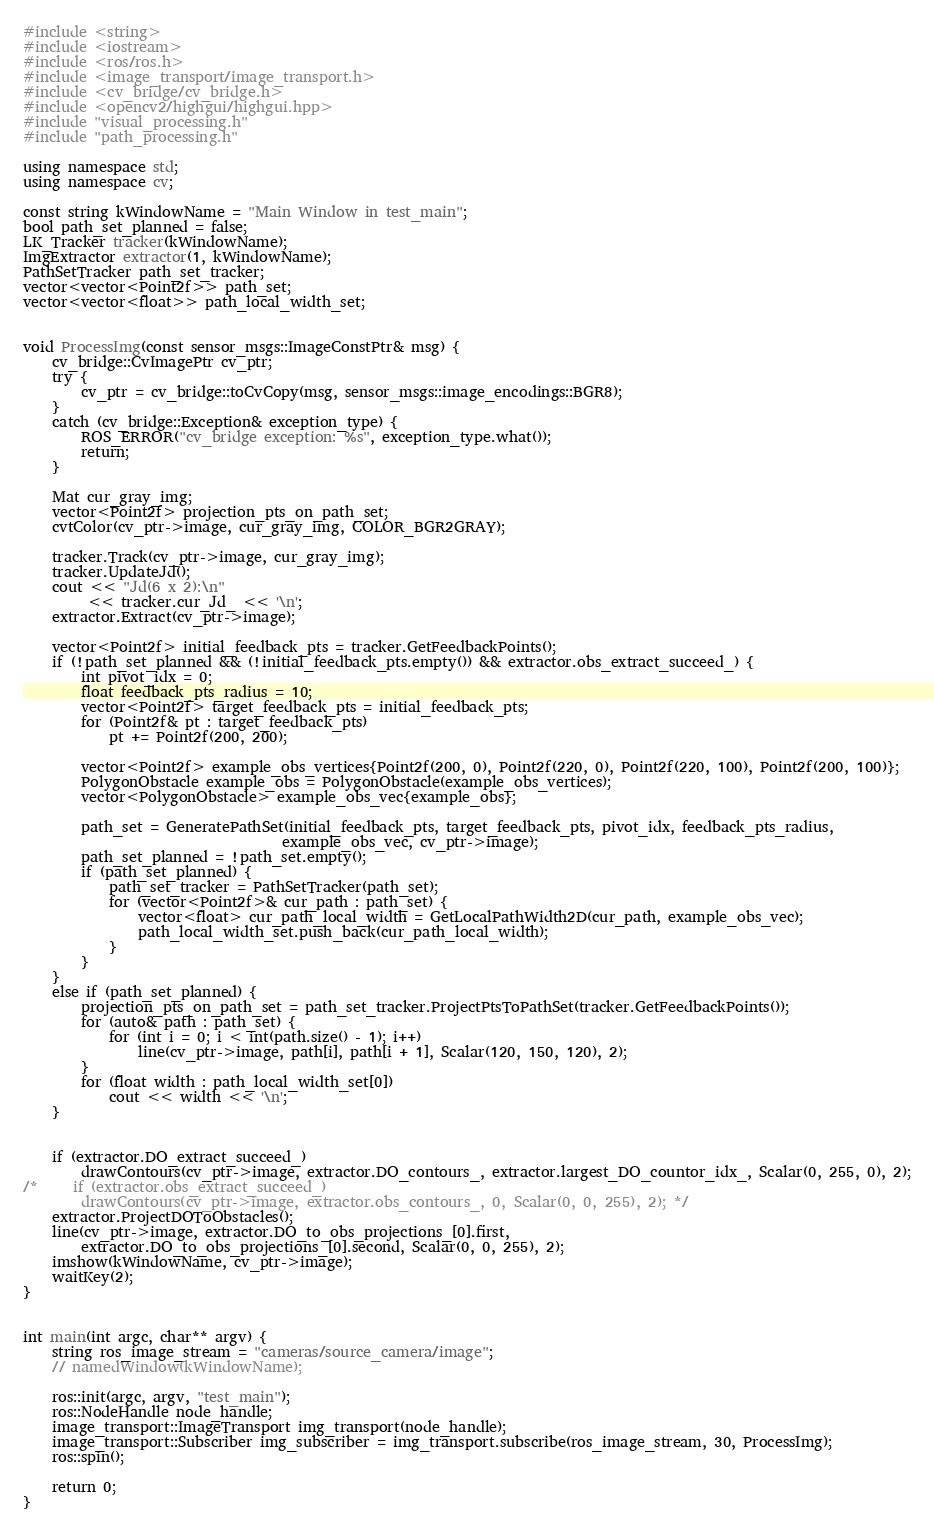Convert code to text. <code><loc_0><loc_0><loc_500><loc_500><_C++_>#include <string>
#include <iostream>
#include <ros/ros.h>
#include <image_transport/image_transport.h>
#include <cv_bridge/cv_bridge.h>
#include <opencv2/highgui/highgui.hpp>
#include "visual_processing.h"
#include "path_processing.h"

using namespace std;
using namespace cv;

const string kWindowName = "Main Window in test_main";
bool path_set_planned = false;
LK_Tracker tracker(kWindowName);
ImgExtractor extractor(1, kWindowName);
PathSetTracker path_set_tracker;
vector<vector<Point2f>> path_set;
vector<vector<float>> path_local_width_set;


void ProcessImg(const sensor_msgs::ImageConstPtr& msg) {
    cv_bridge::CvImagePtr cv_ptr;
    try {
        cv_ptr = cv_bridge::toCvCopy(msg, sensor_msgs::image_encodings::BGR8);
    }
    catch (cv_bridge::Exception& exception_type) {
        ROS_ERROR("cv_bridge exception: %s", exception_type.what());
        return;
    }

    Mat cur_gray_img;
    vector<Point2f> projection_pts_on_path_set;
    cvtColor(cv_ptr->image, cur_gray_img, COLOR_BGR2GRAY); 
    
    tracker.Track(cv_ptr->image, cur_gray_img);   
    tracker.UpdateJd();
    cout << "Jd(6 x 2):\n" 
         << tracker.cur_Jd_ << '\n';
    extractor.Extract(cv_ptr->image);
    
    vector<Point2f> initial_feedback_pts = tracker.GetFeedbackPoints();
    if (!path_set_planned && (!initial_feedback_pts.empty()) && extractor.obs_extract_succeed_) {
        int pivot_idx = 0;
        float feedback_pts_radius = 10;
        vector<Point2f> target_feedback_pts = initial_feedback_pts;
        for (Point2f& pt : target_feedback_pts)
            pt += Point2f(200, 200);

        vector<Point2f> example_obs_vertices{Point2f(200, 0), Point2f(220, 0), Point2f(220, 100), Point2f(200, 100)};
        PolygonObstacle example_obs = PolygonObstacle(example_obs_vertices);
        vector<PolygonObstacle> example_obs_vec{example_obs};
        
        path_set = GeneratePathSet(initial_feedback_pts, target_feedback_pts, pivot_idx, feedback_pts_radius,
                                    example_obs_vec, cv_ptr->image);
        path_set_planned = !path_set.empty();
        if (path_set_planned) {
            path_set_tracker = PathSetTracker(path_set);
            for (vector<Point2f>& cur_path : path_set) {
                vector<float> cur_path_local_width = GetLocalPathWidth2D(cur_path, example_obs_vec);
                path_local_width_set.push_back(cur_path_local_width);
            }
        }
    }
    else if (path_set_planned) {
        projection_pts_on_path_set = path_set_tracker.ProjectPtsToPathSet(tracker.GetFeedbackPoints());
        for (auto& path : path_set) {
            for (int i = 0; i < int(path.size() - 1); i++)
                line(cv_ptr->image, path[i], path[i + 1], Scalar(120, 150, 120), 2);
        }
        for (float width : path_local_width_set[0])
            cout << width << '\n';
    }


    if (extractor.DO_extract_succeed_)
        drawContours(cv_ptr->image, extractor.DO_contours_, extractor.largest_DO_countor_idx_, Scalar(0, 255, 0), 2);
/*     if (extractor.obs_extract_succeed_)
        drawContours(cv_ptr->image, extractor.obs_contours_, 0, Scalar(0, 0, 255), 2); */
    extractor.ProjectDOToObstacles();
    line(cv_ptr->image, extractor.DO_to_obs_projections_[0].first, 
        extractor.DO_to_obs_projections_[0].second, Scalar(0, 0, 255), 2);
    imshow(kWindowName, cv_ptr->image);
    waitKey(2);
}


int main(int argc, char** argv) {
    string ros_image_stream = "cameras/source_camera/image";
    // namedWindow(kWindowName);
    
    ros::init(argc, argv, "test_main");
    ros::NodeHandle node_handle;
    image_transport::ImageTransport img_transport(node_handle);
    image_transport::Subscriber img_subscriber = img_transport.subscribe(ros_image_stream, 30, ProcessImg);
    ros::spin();

    return 0;
}</code> 